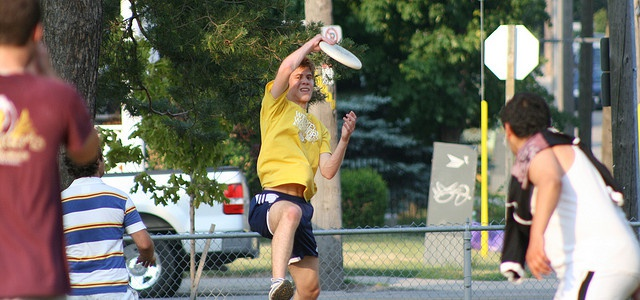Describe the objects in this image and their specific colors. I can see people in maroon, brown, and black tones, people in maroon, white, black, salmon, and tan tones, people in maroon, khaki, tan, and black tones, truck in maroon, white, gray, black, and darkgray tones, and people in maroon, lavender, blue, and black tones in this image. 